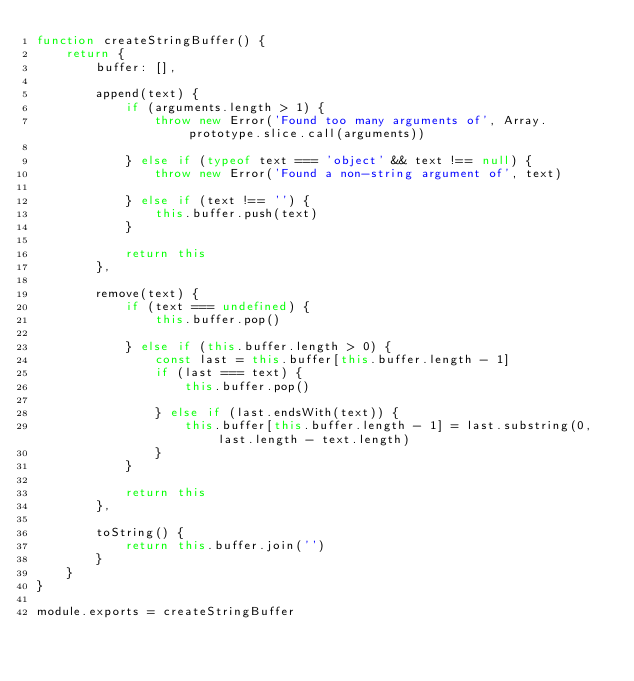Convert code to text. <code><loc_0><loc_0><loc_500><loc_500><_JavaScript_>function createStringBuffer() {
	return {
		buffer: [],

		append(text) {
			if (arguments.length > 1) {
				throw new Error('Found too many arguments of', Array.prototype.slice.call(arguments))

			} else if (typeof text === 'object' && text !== null) {
				throw new Error('Found a non-string argument of', text)

			} else if (text !== '') {
				this.buffer.push(text)
			}

			return this
		},

		remove(text) {
			if (text === undefined) {
				this.buffer.pop()

			} else if (this.buffer.length > 0) {
				const last = this.buffer[this.buffer.length - 1]
				if (last === text) {
					this.buffer.pop()

				} else if (last.endsWith(text)) {
					this.buffer[this.buffer.length - 1] = last.substring(0, last.length - text.length)
				}
			}

			return this
		},

		toString() {
			return this.buffer.join('')
		}
	}
}

module.exports = createStringBuffer</code> 